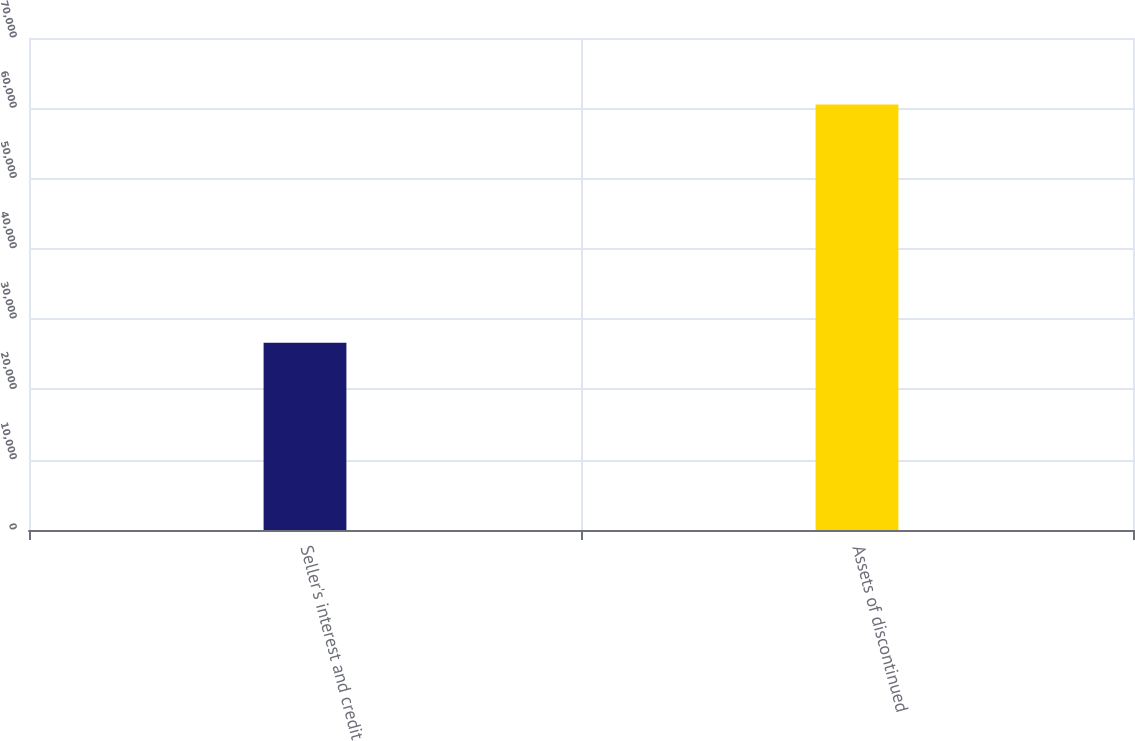Convert chart. <chart><loc_0><loc_0><loc_500><loc_500><bar_chart><fcel>Seller's interest and credit<fcel>Assets of discontinued<nl><fcel>26633<fcel>60527<nl></chart> 